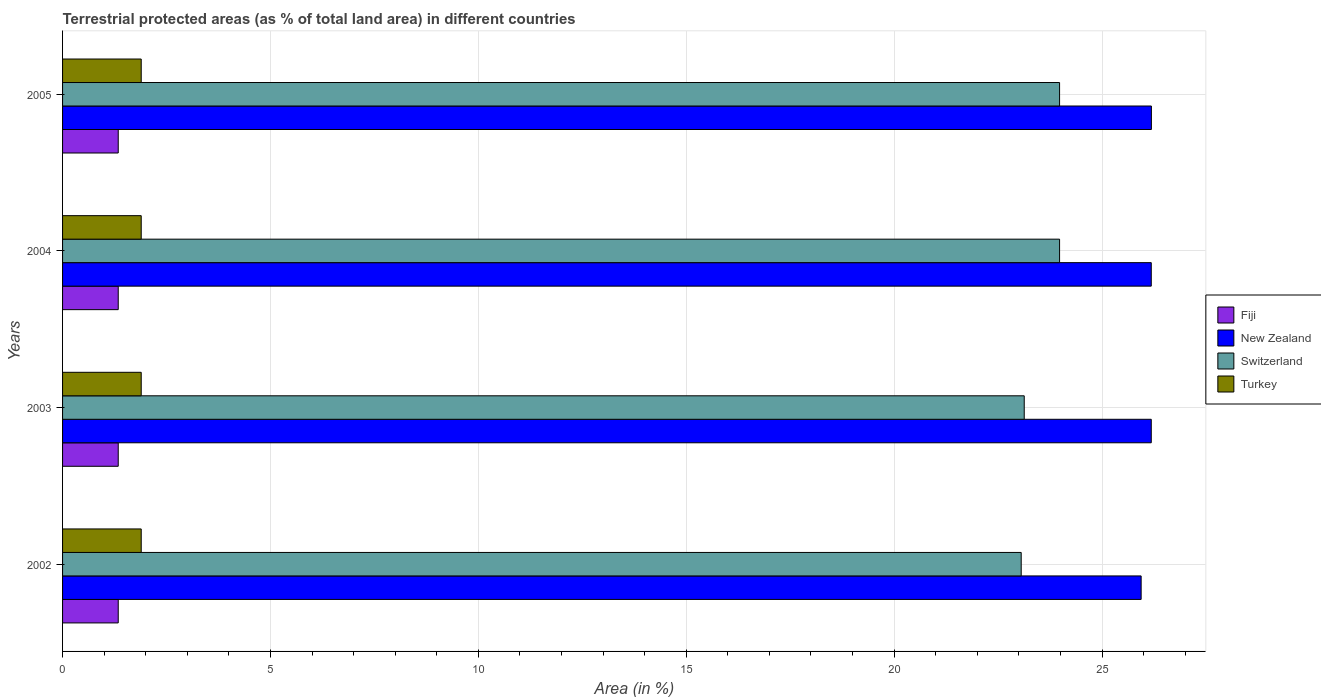How many different coloured bars are there?
Make the answer very short. 4. How many groups of bars are there?
Offer a terse response. 4. Are the number of bars on each tick of the Y-axis equal?
Give a very brief answer. Yes. How many bars are there on the 2nd tick from the top?
Your answer should be compact. 4. How many bars are there on the 2nd tick from the bottom?
Keep it short and to the point. 4. What is the percentage of terrestrial protected land in New Zealand in 2002?
Keep it short and to the point. 25.94. Across all years, what is the maximum percentage of terrestrial protected land in Switzerland?
Your answer should be compact. 23.98. Across all years, what is the minimum percentage of terrestrial protected land in New Zealand?
Offer a very short reply. 25.94. In which year was the percentage of terrestrial protected land in Fiji maximum?
Offer a terse response. 2002. What is the total percentage of terrestrial protected land in New Zealand in the graph?
Offer a very short reply. 104.5. What is the difference between the percentage of terrestrial protected land in Turkey in 2002 and that in 2005?
Provide a succinct answer. 0. What is the difference between the percentage of terrestrial protected land in Fiji in 2003 and the percentage of terrestrial protected land in Switzerland in 2002?
Your response must be concise. -21.72. What is the average percentage of terrestrial protected land in Switzerland per year?
Provide a short and direct response. 23.54. In the year 2003, what is the difference between the percentage of terrestrial protected land in Switzerland and percentage of terrestrial protected land in Fiji?
Give a very brief answer. 21.79. Is the percentage of terrestrial protected land in Fiji in 2003 less than that in 2005?
Offer a terse response. No. What is the difference between the highest and the second highest percentage of terrestrial protected land in Switzerland?
Offer a terse response. 0. Is the sum of the percentage of terrestrial protected land in Switzerland in 2004 and 2005 greater than the maximum percentage of terrestrial protected land in Turkey across all years?
Provide a short and direct response. Yes. What does the 2nd bar from the top in 2003 represents?
Your answer should be very brief. Switzerland. What does the 2nd bar from the bottom in 2003 represents?
Your answer should be compact. New Zealand. Are all the bars in the graph horizontal?
Offer a very short reply. Yes. What is the difference between two consecutive major ticks on the X-axis?
Offer a very short reply. 5. Are the values on the major ticks of X-axis written in scientific E-notation?
Provide a succinct answer. No. Does the graph contain any zero values?
Offer a very short reply. No. Does the graph contain grids?
Provide a succinct answer. Yes. Where does the legend appear in the graph?
Provide a succinct answer. Center right. What is the title of the graph?
Your answer should be very brief. Terrestrial protected areas (as % of total land area) in different countries. Does "Qatar" appear as one of the legend labels in the graph?
Your response must be concise. No. What is the label or title of the X-axis?
Your answer should be very brief. Area (in %). What is the label or title of the Y-axis?
Provide a succinct answer. Years. What is the Area (in %) in Fiji in 2002?
Your answer should be compact. 1.34. What is the Area (in %) in New Zealand in 2002?
Give a very brief answer. 25.94. What is the Area (in %) of Switzerland in 2002?
Make the answer very short. 23.06. What is the Area (in %) in Turkey in 2002?
Keep it short and to the point. 1.89. What is the Area (in %) in Fiji in 2003?
Provide a short and direct response. 1.34. What is the Area (in %) of New Zealand in 2003?
Provide a short and direct response. 26.18. What is the Area (in %) in Switzerland in 2003?
Make the answer very short. 23.13. What is the Area (in %) in Turkey in 2003?
Provide a succinct answer. 1.89. What is the Area (in %) of Fiji in 2004?
Provide a short and direct response. 1.34. What is the Area (in %) of New Zealand in 2004?
Ensure brevity in your answer.  26.18. What is the Area (in %) in Switzerland in 2004?
Your response must be concise. 23.98. What is the Area (in %) in Turkey in 2004?
Your answer should be very brief. 1.89. What is the Area (in %) of Fiji in 2005?
Your response must be concise. 1.34. What is the Area (in %) in New Zealand in 2005?
Your answer should be very brief. 26.19. What is the Area (in %) in Switzerland in 2005?
Your answer should be compact. 23.98. What is the Area (in %) of Turkey in 2005?
Give a very brief answer. 1.89. Across all years, what is the maximum Area (in %) in Fiji?
Keep it short and to the point. 1.34. Across all years, what is the maximum Area (in %) of New Zealand?
Give a very brief answer. 26.19. Across all years, what is the maximum Area (in %) of Switzerland?
Your response must be concise. 23.98. Across all years, what is the maximum Area (in %) of Turkey?
Provide a short and direct response. 1.89. Across all years, what is the minimum Area (in %) in Fiji?
Your response must be concise. 1.34. Across all years, what is the minimum Area (in %) of New Zealand?
Keep it short and to the point. 25.94. Across all years, what is the minimum Area (in %) in Switzerland?
Offer a terse response. 23.06. Across all years, what is the minimum Area (in %) of Turkey?
Make the answer very short. 1.89. What is the total Area (in %) in Fiji in the graph?
Provide a succinct answer. 5.36. What is the total Area (in %) in New Zealand in the graph?
Provide a short and direct response. 104.5. What is the total Area (in %) of Switzerland in the graph?
Offer a terse response. 94.15. What is the total Area (in %) of Turkey in the graph?
Give a very brief answer. 7.57. What is the difference between the Area (in %) of New Zealand in 2002 and that in 2003?
Offer a very short reply. -0.24. What is the difference between the Area (in %) in Switzerland in 2002 and that in 2003?
Ensure brevity in your answer.  -0.07. What is the difference between the Area (in %) in New Zealand in 2002 and that in 2004?
Make the answer very short. -0.24. What is the difference between the Area (in %) of Switzerland in 2002 and that in 2004?
Your response must be concise. -0.92. What is the difference between the Area (in %) of Fiji in 2002 and that in 2005?
Your answer should be very brief. 0. What is the difference between the Area (in %) in New Zealand in 2002 and that in 2005?
Give a very brief answer. -0.25. What is the difference between the Area (in %) of Switzerland in 2002 and that in 2005?
Your answer should be very brief. -0.92. What is the difference between the Area (in %) of New Zealand in 2003 and that in 2004?
Make the answer very short. 0. What is the difference between the Area (in %) of Switzerland in 2003 and that in 2004?
Your answer should be compact. -0.85. What is the difference between the Area (in %) of Fiji in 2003 and that in 2005?
Offer a terse response. 0. What is the difference between the Area (in %) of New Zealand in 2003 and that in 2005?
Keep it short and to the point. -0. What is the difference between the Area (in %) in Switzerland in 2003 and that in 2005?
Give a very brief answer. -0.85. What is the difference between the Area (in %) in Fiji in 2004 and that in 2005?
Give a very brief answer. 0. What is the difference between the Area (in %) of New Zealand in 2004 and that in 2005?
Provide a short and direct response. -0. What is the difference between the Area (in %) of Switzerland in 2004 and that in 2005?
Your response must be concise. 0. What is the difference between the Area (in %) of Fiji in 2002 and the Area (in %) of New Zealand in 2003?
Your answer should be compact. -24.85. What is the difference between the Area (in %) in Fiji in 2002 and the Area (in %) in Switzerland in 2003?
Provide a succinct answer. -21.79. What is the difference between the Area (in %) of Fiji in 2002 and the Area (in %) of Turkey in 2003?
Your answer should be very brief. -0.55. What is the difference between the Area (in %) in New Zealand in 2002 and the Area (in %) in Switzerland in 2003?
Make the answer very short. 2.81. What is the difference between the Area (in %) in New Zealand in 2002 and the Area (in %) in Turkey in 2003?
Your answer should be compact. 24.05. What is the difference between the Area (in %) of Switzerland in 2002 and the Area (in %) of Turkey in 2003?
Offer a terse response. 21.17. What is the difference between the Area (in %) in Fiji in 2002 and the Area (in %) in New Zealand in 2004?
Your response must be concise. -24.85. What is the difference between the Area (in %) in Fiji in 2002 and the Area (in %) in Switzerland in 2004?
Your answer should be very brief. -22.64. What is the difference between the Area (in %) of Fiji in 2002 and the Area (in %) of Turkey in 2004?
Your response must be concise. -0.55. What is the difference between the Area (in %) of New Zealand in 2002 and the Area (in %) of Switzerland in 2004?
Provide a succinct answer. 1.96. What is the difference between the Area (in %) of New Zealand in 2002 and the Area (in %) of Turkey in 2004?
Keep it short and to the point. 24.05. What is the difference between the Area (in %) in Switzerland in 2002 and the Area (in %) in Turkey in 2004?
Make the answer very short. 21.17. What is the difference between the Area (in %) in Fiji in 2002 and the Area (in %) in New Zealand in 2005?
Offer a very short reply. -24.85. What is the difference between the Area (in %) of Fiji in 2002 and the Area (in %) of Switzerland in 2005?
Provide a short and direct response. -22.64. What is the difference between the Area (in %) in Fiji in 2002 and the Area (in %) in Turkey in 2005?
Offer a very short reply. -0.55. What is the difference between the Area (in %) in New Zealand in 2002 and the Area (in %) in Switzerland in 2005?
Your response must be concise. 1.96. What is the difference between the Area (in %) of New Zealand in 2002 and the Area (in %) of Turkey in 2005?
Your answer should be very brief. 24.05. What is the difference between the Area (in %) in Switzerland in 2002 and the Area (in %) in Turkey in 2005?
Your response must be concise. 21.17. What is the difference between the Area (in %) of Fiji in 2003 and the Area (in %) of New Zealand in 2004?
Provide a short and direct response. -24.85. What is the difference between the Area (in %) of Fiji in 2003 and the Area (in %) of Switzerland in 2004?
Provide a short and direct response. -22.64. What is the difference between the Area (in %) of Fiji in 2003 and the Area (in %) of Turkey in 2004?
Your answer should be compact. -0.55. What is the difference between the Area (in %) in New Zealand in 2003 and the Area (in %) in Switzerland in 2004?
Provide a succinct answer. 2.21. What is the difference between the Area (in %) of New Zealand in 2003 and the Area (in %) of Turkey in 2004?
Provide a succinct answer. 24.29. What is the difference between the Area (in %) in Switzerland in 2003 and the Area (in %) in Turkey in 2004?
Offer a terse response. 21.24. What is the difference between the Area (in %) of Fiji in 2003 and the Area (in %) of New Zealand in 2005?
Your response must be concise. -24.85. What is the difference between the Area (in %) of Fiji in 2003 and the Area (in %) of Switzerland in 2005?
Give a very brief answer. -22.64. What is the difference between the Area (in %) in Fiji in 2003 and the Area (in %) in Turkey in 2005?
Ensure brevity in your answer.  -0.55. What is the difference between the Area (in %) of New Zealand in 2003 and the Area (in %) of Switzerland in 2005?
Your answer should be compact. 2.21. What is the difference between the Area (in %) in New Zealand in 2003 and the Area (in %) in Turkey in 2005?
Provide a short and direct response. 24.29. What is the difference between the Area (in %) of Switzerland in 2003 and the Area (in %) of Turkey in 2005?
Make the answer very short. 21.24. What is the difference between the Area (in %) in Fiji in 2004 and the Area (in %) in New Zealand in 2005?
Make the answer very short. -24.85. What is the difference between the Area (in %) of Fiji in 2004 and the Area (in %) of Switzerland in 2005?
Your answer should be very brief. -22.64. What is the difference between the Area (in %) in Fiji in 2004 and the Area (in %) in Turkey in 2005?
Your response must be concise. -0.55. What is the difference between the Area (in %) of New Zealand in 2004 and the Area (in %) of Switzerland in 2005?
Your response must be concise. 2.21. What is the difference between the Area (in %) in New Zealand in 2004 and the Area (in %) in Turkey in 2005?
Make the answer very short. 24.29. What is the difference between the Area (in %) of Switzerland in 2004 and the Area (in %) of Turkey in 2005?
Provide a short and direct response. 22.09. What is the average Area (in %) in Fiji per year?
Your answer should be very brief. 1.34. What is the average Area (in %) of New Zealand per year?
Your response must be concise. 26.12. What is the average Area (in %) in Switzerland per year?
Keep it short and to the point. 23.54. What is the average Area (in %) in Turkey per year?
Your answer should be compact. 1.89. In the year 2002, what is the difference between the Area (in %) of Fiji and Area (in %) of New Zealand?
Offer a terse response. -24.6. In the year 2002, what is the difference between the Area (in %) of Fiji and Area (in %) of Switzerland?
Provide a succinct answer. -21.72. In the year 2002, what is the difference between the Area (in %) in Fiji and Area (in %) in Turkey?
Your response must be concise. -0.55. In the year 2002, what is the difference between the Area (in %) in New Zealand and Area (in %) in Switzerland?
Keep it short and to the point. 2.88. In the year 2002, what is the difference between the Area (in %) in New Zealand and Area (in %) in Turkey?
Offer a very short reply. 24.05. In the year 2002, what is the difference between the Area (in %) in Switzerland and Area (in %) in Turkey?
Your response must be concise. 21.17. In the year 2003, what is the difference between the Area (in %) in Fiji and Area (in %) in New Zealand?
Keep it short and to the point. -24.85. In the year 2003, what is the difference between the Area (in %) of Fiji and Area (in %) of Switzerland?
Give a very brief answer. -21.79. In the year 2003, what is the difference between the Area (in %) in Fiji and Area (in %) in Turkey?
Make the answer very short. -0.55. In the year 2003, what is the difference between the Area (in %) in New Zealand and Area (in %) in Switzerland?
Your response must be concise. 3.06. In the year 2003, what is the difference between the Area (in %) of New Zealand and Area (in %) of Turkey?
Provide a short and direct response. 24.29. In the year 2003, what is the difference between the Area (in %) of Switzerland and Area (in %) of Turkey?
Give a very brief answer. 21.24. In the year 2004, what is the difference between the Area (in %) of Fiji and Area (in %) of New Zealand?
Your answer should be compact. -24.85. In the year 2004, what is the difference between the Area (in %) in Fiji and Area (in %) in Switzerland?
Your response must be concise. -22.64. In the year 2004, what is the difference between the Area (in %) in Fiji and Area (in %) in Turkey?
Your answer should be very brief. -0.55. In the year 2004, what is the difference between the Area (in %) of New Zealand and Area (in %) of Switzerland?
Your answer should be very brief. 2.21. In the year 2004, what is the difference between the Area (in %) of New Zealand and Area (in %) of Turkey?
Offer a very short reply. 24.29. In the year 2004, what is the difference between the Area (in %) of Switzerland and Area (in %) of Turkey?
Provide a succinct answer. 22.09. In the year 2005, what is the difference between the Area (in %) in Fiji and Area (in %) in New Zealand?
Ensure brevity in your answer.  -24.85. In the year 2005, what is the difference between the Area (in %) in Fiji and Area (in %) in Switzerland?
Give a very brief answer. -22.64. In the year 2005, what is the difference between the Area (in %) in Fiji and Area (in %) in Turkey?
Your answer should be very brief. -0.55. In the year 2005, what is the difference between the Area (in %) of New Zealand and Area (in %) of Switzerland?
Your response must be concise. 2.21. In the year 2005, what is the difference between the Area (in %) in New Zealand and Area (in %) in Turkey?
Your answer should be very brief. 24.3. In the year 2005, what is the difference between the Area (in %) in Switzerland and Area (in %) in Turkey?
Keep it short and to the point. 22.09. What is the ratio of the Area (in %) of Fiji in 2002 to that in 2003?
Ensure brevity in your answer.  1. What is the ratio of the Area (in %) of New Zealand in 2002 to that in 2003?
Your answer should be compact. 0.99. What is the ratio of the Area (in %) of Fiji in 2002 to that in 2004?
Your answer should be compact. 1. What is the ratio of the Area (in %) of New Zealand in 2002 to that in 2004?
Your answer should be compact. 0.99. What is the ratio of the Area (in %) in Switzerland in 2002 to that in 2004?
Provide a short and direct response. 0.96. What is the ratio of the Area (in %) in Turkey in 2002 to that in 2004?
Keep it short and to the point. 1. What is the ratio of the Area (in %) in Fiji in 2002 to that in 2005?
Provide a succinct answer. 1. What is the ratio of the Area (in %) of New Zealand in 2002 to that in 2005?
Your answer should be compact. 0.99. What is the ratio of the Area (in %) of Switzerland in 2002 to that in 2005?
Your answer should be very brief. 0.96. What is the ratio of the Area (in %) of Turkey in 2002 to that in 2005?
Your answer should be very brief. 1. What is the ratio of the Area (in %) in Fiji in 2003 to that in 2004?
Keep it short and to the point. 1. What is the ratio of the Area (in %) of New Zealand in 2003 to that in 2004?
Provide a short and direct response. 1. What is the ratio of the Area (in %) in Switzerland in 2003 to that in 2004?
Ensure brevity in your answer.  0.96. What is the ratio of the Area (in %) of New Zealand in 2003 to that in 2005?
Your answer should be very brief. 1. What is the ratio of the Area (in %) in Switzerland in 2003 to that in 2005?
Give a very brief answer. 0.96. What is the ratio of the Area (in %) of Turkey in 2003 to that in 2005?
Make the answer very short. 1. What is the ratio of the Area (in %) of Fiji in 2004 to that in 2005?
Provide a short and direct response. 1. What is the ratio of the Area (in %) of Turkey in 2004 to that in 2005?
Offer a very short reply. 1. What is the difference between the highest and the second highest Area (in %) in New Zealand?
Provide a succinct answer. 0. What is the difference between the highest and the lowest Area (in %) in New Zealand?
Provide a succinct answer. 0.25. 